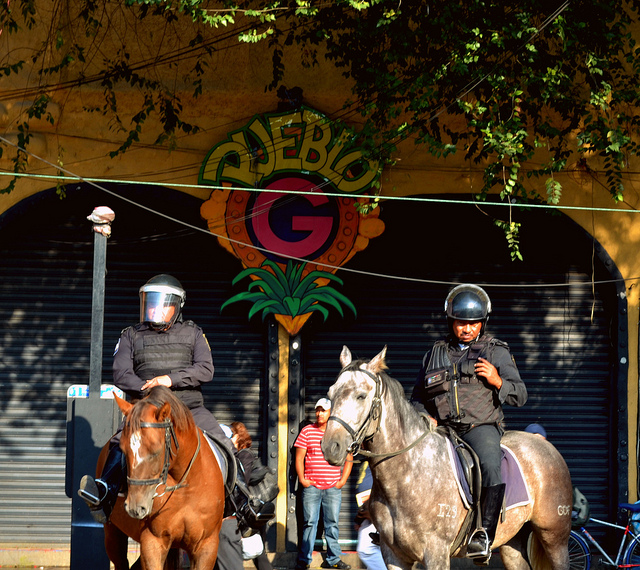Identify the text displayed in this image. PUEBLO G 